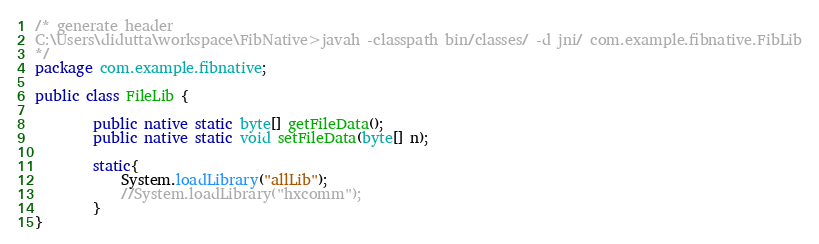Convert code to text. <code><loc_0><loc_0><loc_500><loc_500><_Java_>/* generate header 
C:\Users\didutta\workspace\FibNative>javah -classpath bin/classes/ -d jni/ com.example.fibnative.FibLib
*/
package com.example.fibnative;

public class FileLib {
	     
		public native static byte[] getFileData();
		public native static void setFileData(byte[] n);		
		
		static{
			System.loadLibrary("allLib");
			//System.loadLibrary("hxcomm");
		}
}
</code> 